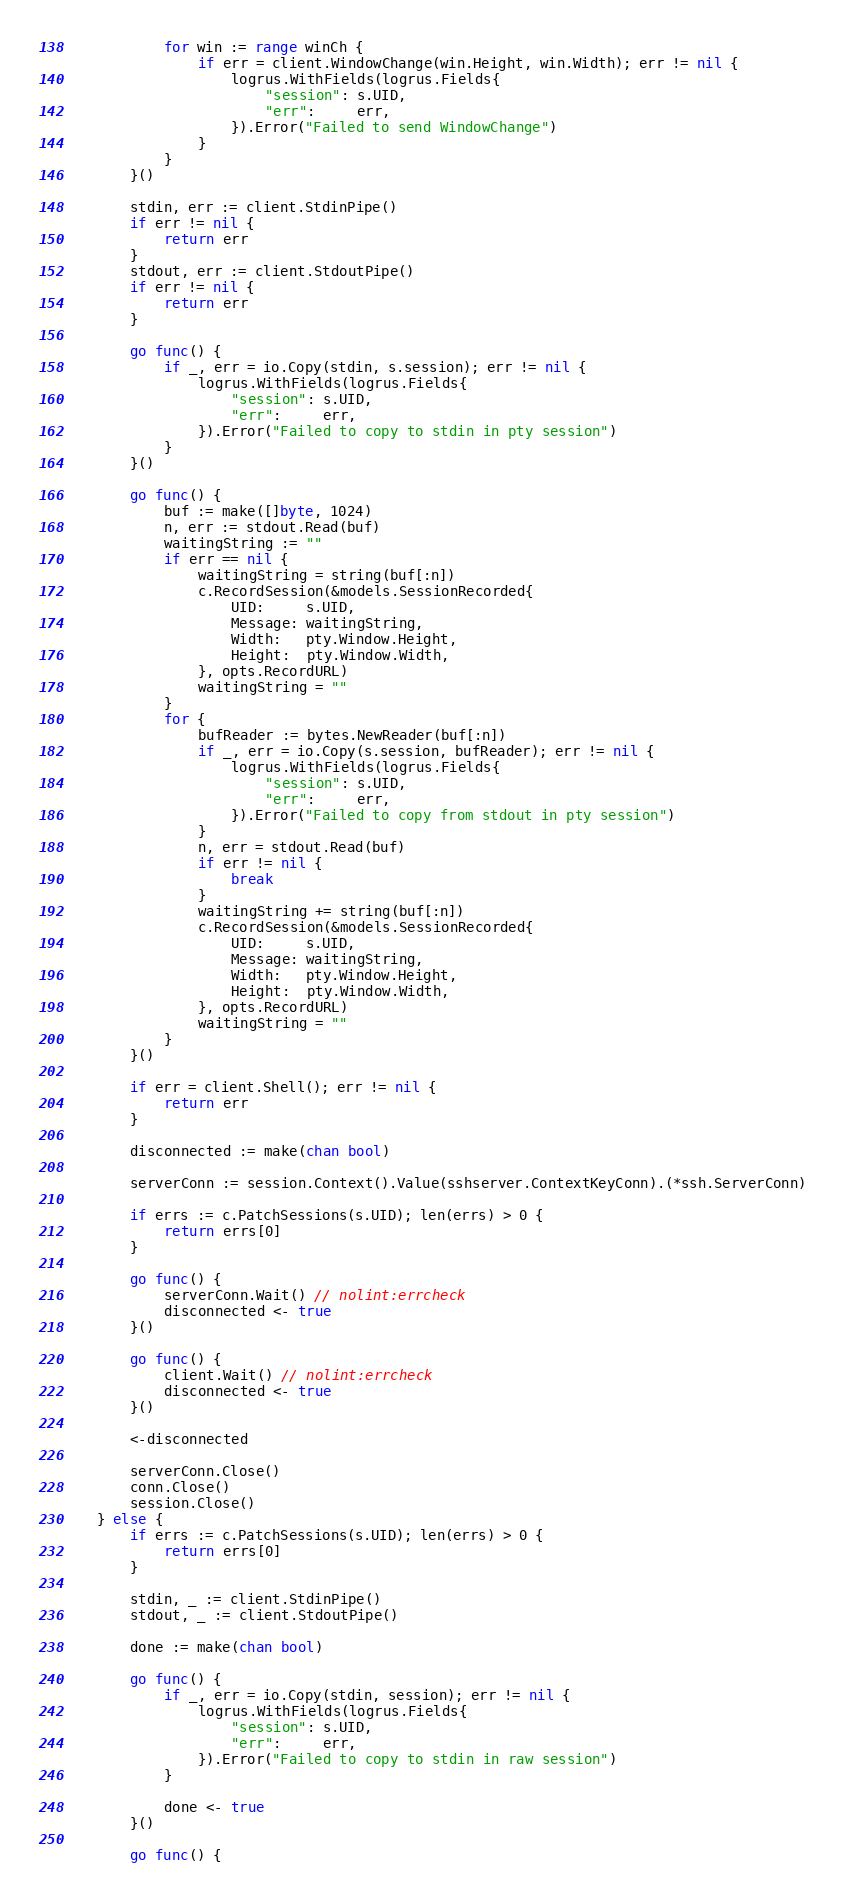Convert code to text. <code><loc_0><loc_0><loc_500><loc_500><_Go_>			for win := range winCh {
				if err = client.WindowChange(win.Height, win.Width); err != nil {
					logrus.WithFields(logrus.Fields{
						"session": s.UID,
						"err":     err,
					}).Error("Failed to send WindowChange")
				}
			}
		}()

		stdin, err := client.StdinPipe()
		if err != nil {
			return err
		}
		stdout, err := client.StdoutPipe()
		if err != nil {
			return err
		}

		go func() {
			if _, err = io.Copy(stdin, s.session); err != nil {
				logrus.WithFields(logrus.Fields{
					"session": s.UID,
					"err":     err,
				}).Error("Failed to copy to stdin in pty session")
			}
		}()

		go func() {
			buf := make([]byte, 1024)
			n, err := stdout.Read(buf)
			waitingString := ""
			if err == nil {
				waitingString = string(buf[:n])
				c.RecordSession(&models.SessionRecorded{
					UID:     s.UID,
					Message: waitingString,
					Width:   pty.Window.Height,
					Height:  pty.Window.Width,
				}, opts.RecordURL)
				waitingString = ""
			}
			for {
				bufReader := bytes.NewReader(buf[:n])
				if _, err = io.Copy(s.session, bufReader); err != nil {
					logrus.WithFields(logrus.Fields{
						"session": s.UID,
						"err":     err,
					}).Error("Failed to copy from stdout in pty session")
				}
				n, err = stdout.Read(buf)
				if err != nil {
					break
				}
				waitingString += string(buf[:n])
				c.RecordSession(&models.SessionRecorded{
					UID:     s.UID,
					Message: waitingString,
					Width:   pty.Window.Height,
					Height:  pty.Window.Width,
				}, opts.RecordURL)
				waitingString = ""
			}
		}()

		if err = client.Shell(); err != nil {
			return err
		}

		disconnected := make(chan bool)

		serverConn := session.Context().Value(sshserver.ContextKeyConn).(*ssh.ServerConn)

		if errs := c.PatchSessions(s.UID); len(errs) > 0 {
			return errs[0]
		}

		go func() {
			serverConn.Wait() // nolint:errcheck
			disconnected <- true
		}()

		go func() {
			client.Wait() // nolint:errcheck
			disconnected <- true
		}()

		<-disconnected

		serverConn.Close()
		conn.Close()
		session.Close()
	} else {
		if errs := c.PatchSessions(s.UID); len(errs) > 0 {
			return errs[0]
		}

		stdin, _ := client.StdinPipe()
		stdout, _ := client.StdoutPipe()

		done := make(chan bool)

		go func() {
			if _, err = io.Copy(stdin, session); err != nil {
				logrus.WithFields(logrus.Fields{
					"session": s.UID,
					"err":     err,
				}).Error("Failed to copy to stdin in raw session")
			}

			done <- true
		}()

		go func() {</code> 